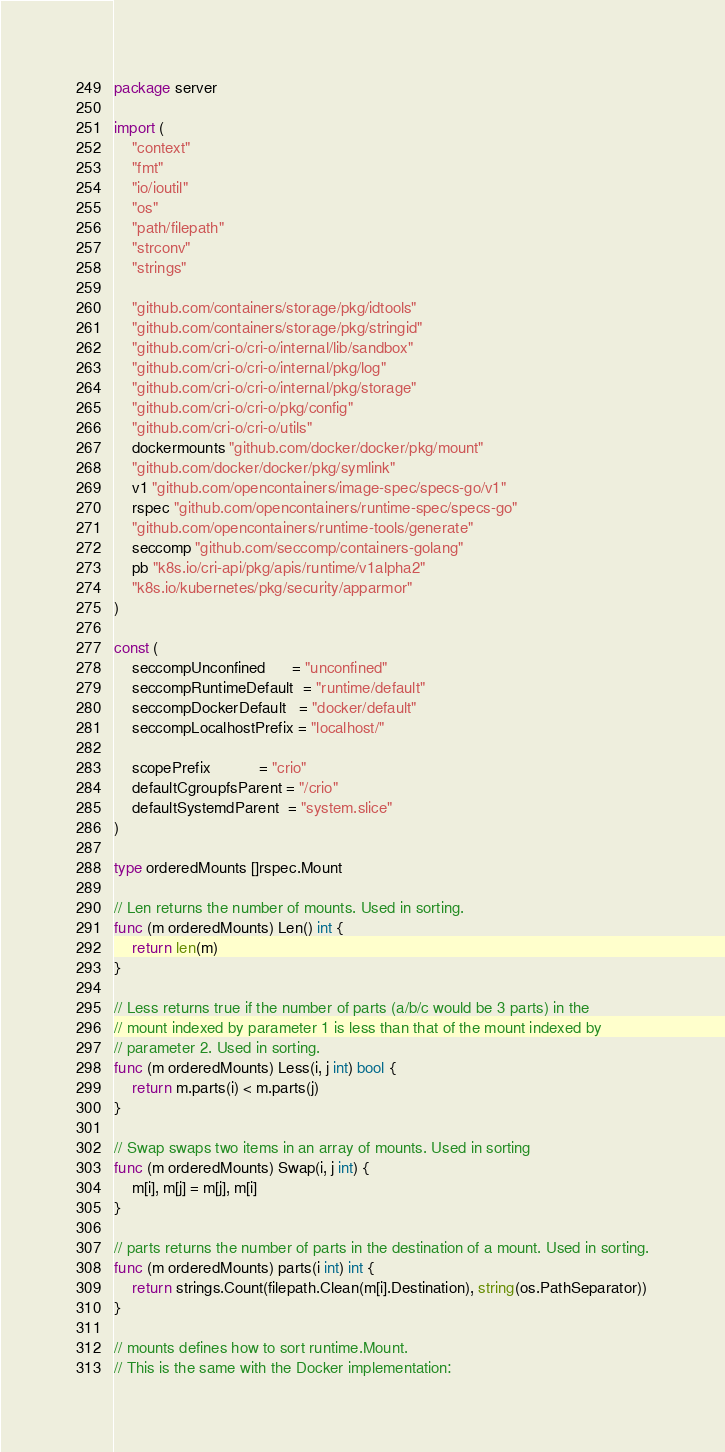<code> <loc_0><loc_0><loc_500><loc_500><_Go_>package server

import (
	"context"
	"fmt"
	"io/ioutil"
	"os"
	"path/filepath"
	"strconv"
	"strings"

	"github.com/containers/storage/pkg/idtools"
	"github.com/containers/storage/pkg/stringid"
	"github.com/cri-o/cri-o/internal/lib/sandbox"
	"github.com/cri-o/cri-o/internal/pkg/log"
	"github.com/cri-o/cri-o/internal/pkg/storage"
	"github.com/cri-o/cri-o/pkg/config"
	"github.com/cri-o/cri-o/utils"
	dockermounts "github.com/docker/docker/pkg/mount"
	"github.com/docker/docker/pkg/symlink"
	v1 "github.com/opencontainers/image-spec/specs-go/v1"
	rspec "github.com/opencontainers/runtime-spec/specs-go"
	"github.com/opencontainers/runtime-tools/generate"
	seccomp "github.com/seccomp/containers-golang"
	pb "k8s.io/cri-api/pkg/apis/runtime/v1alpha2"
	"k8s.io/kubernetes/pkg/security/apparmor"
)

const (
	seccompUnconfined      = "unconfined"
	seccompRuntimeDefault  = "runtime/default"
	seccompDockerDefault   = "docker/default"
	seccompLocalhostPrefix = "localhost/"

	scopePrefix           = "crio"
	defaultCgroupfsParent = "/crio"
	defaultSystemdParent  = "system.slice"
)

type orderedMounts []rspec.Mount

// Len returns the number of mounts. Used in sorting.
func (m orderedMounts) Len() int {
	return len(m)
}

// Less returns true if the number of parts (a/b/c would be 3 parts) in the
// mount indexed by parameter 1 is less than that of the mount indexed by
// parameter 2. Used in sorting.
func (m orderedMounts) Less(i, j int) bool {
	return m.parts(i) < m.parts(j)
}

// Swap swaps two items in an array of mounts. Used in sorting
func (m orderedMounts) Swap(i, j int) {
	m[i], m[j] = m[j], m[i]
}

// parts returns the number of parts in the destination of a mount. Used in sorting.
func (m orderedMounts) parts(i int) int {
	return strings.Count(filepath.Clean(m[i].Destination), string(os.PathSeparator))
}

// mounts defines how to sort runtime.Mount.
// This is the same with the Docker implementation:</code> 